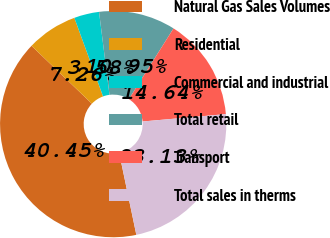Convert chart to OTSL. <chart><loc_0><loc_0><loc_500><loc_500><pie_chart><fcel>Natural Gas Sales Volumes<fcel>Residential<fcel>Commercial and industrial<fcel>Total retail<fcel>Transport<fcel>Total sales in therms<nl><fcel>40.45%<fcel>7.26%<fcel>3.58%<fcel>10.95%<fcel>14.64%<fcel>23.13%<nl></chart> 